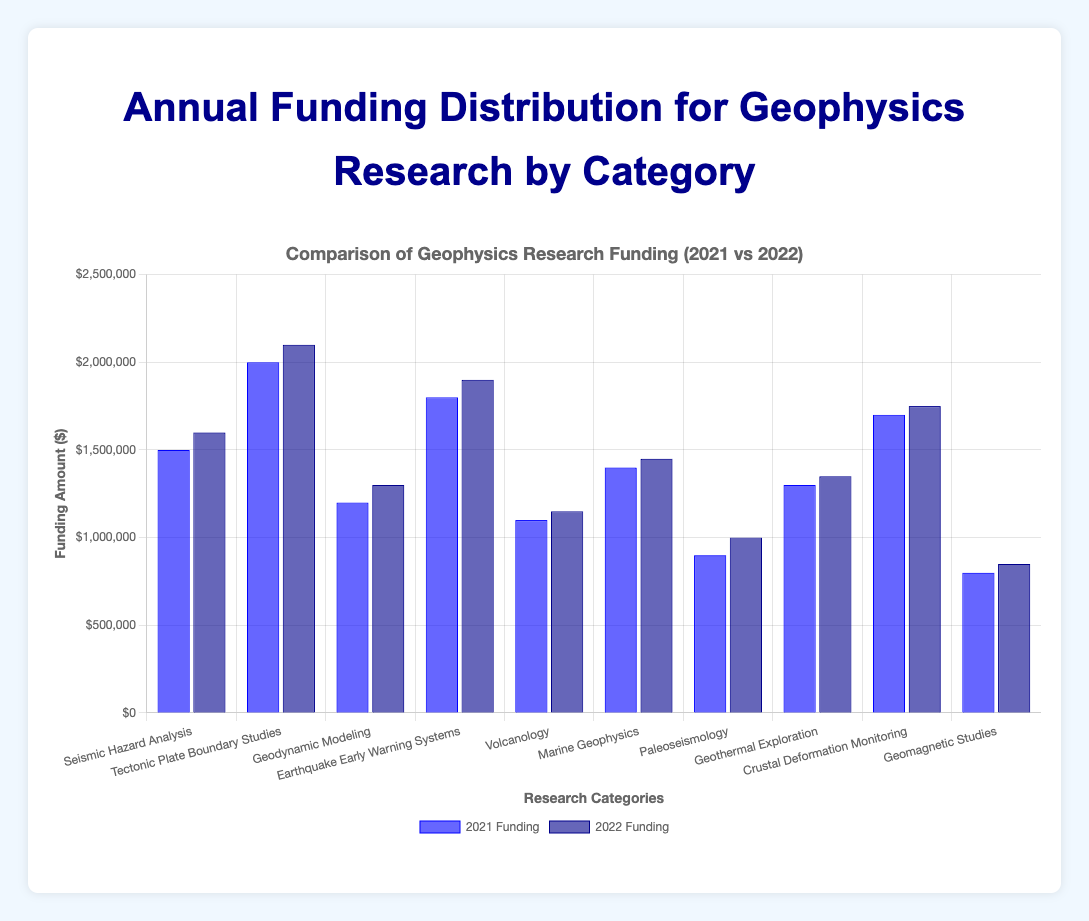Which category received the highest funding in 2022? We look at the highest bar among the dark blue bars. "Tectonic Plate Boundary Studies" has the highest funding at $2,100,000.
Answer: Tectonic Plate Boundary Studies What was the total funding for "Volcanology" across 2021 and 2022? Add the amounts for 2021 and 2022 for "Volcanology": $1,100,000 + $1,150,000 = $2,250,000.
Answer: $2,250,000 Which category saw the biggest increase in funding from 2021 to 2022? Calculate the difference in funding for each category and find the largest increase: "Paleoseismology" increased by $100,000 ($1,000,000 - $900,000).
Answer: Paleoseismology How much more funding did "Earthquake Early Warning Systems" receive compared to "Geomagnetic Studies" in 2021? Subtract the 2021 funding for "Geomagnetic Studies" from that of "Earthquake Early Warning Systems": $1,800,000 - $800,000 = $1,000,000.
Answer: $1,000,000 What is the average funding for "Geodynamic Modeling" in 2021 and 2022? Calculate the average: ($1,200,000 + $1,300,000) / 2 = $1,250,000.
Answer: $1,250,000 Which category had the least funding in 2022? Identify the shortest dark blue bar. "Geomagnetic Studies" had the least funding at $850,000.
Answer: Geomagnetic Studies Was the funding for "Marine Geophysics" higher in 2021 or 2022? Compare the heights of the bars for 2021 and 2022: 2022 ($1,450,000) is higher than 2021 ($1,400,000).
Answer: 2022 What is the total funding for all categories in 2021? Sum all the funding amounts for 2021: $15,000,000.
Answer: $15,000,000 Which category had the smallest difference in funding between 2021 and 2022? Identify the smallest difference: "Marine Geophysics" with a $50,000 increase ($1,450,000 - $1,400,000).
Answer: Marine Geophysics How many categories received more funding in 2022 compared to 2021? Count the number of categories where the 2022 bar is higher than the 2021 bar: 10 categories.
Answer: 10 